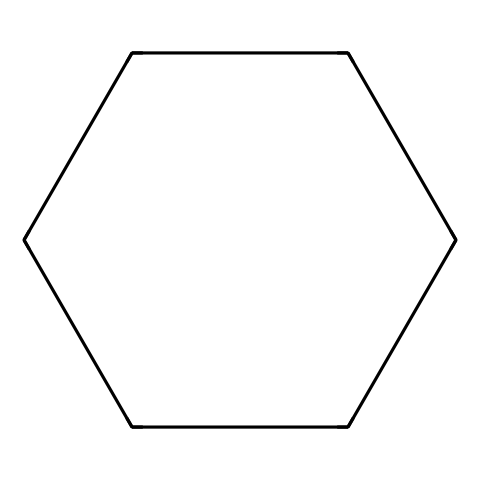What is the name of this chemical? The SMILES representation indicates that this structure corresponds to a six-membered carbon ring with no double bonds, which is characteristic of cyclohexane.
Answer: cyclohexane How many carbon atoms are present in this chemical? By interpreting the SMILES notation, "C1CCCCC1" indicates a total of six carbon atoms forming a cyclic structure.
Answer: six What type of bond is present in the cyclohexane structure? The structure of cyclohexane consists entirely of single bonds, as indicated by the absence of any double bonds in the molecular representation.
Answer: single bonds What is the hybridization of the carbon atoms in cyclohexane? Each carbon atom in the cyclohexane ring is bonded to two other carbons and two hydrogens, which requires sp3 hybridization, typical for alkanes.
Answer: sp3 Is cyclohexane a polar or nonpolar molecule? Due to its symmetrical ring structure and lack of polar functional groups, cyclohexane is evaluated as a nonpolar molecule.
Answer: nonpolar What physical state is cyclohexane at room temperature? Cyclohexane has a boiling point of around 81 degrees Celsius, and at room temperature (about 25 degrees Celsius), it is found in a liquid state.
Answer: liquid What is the main type of chemical reaction that cyclohexane can undergo? Cyclohexane can undergo reactions typical of alkanes, such as substitution and combustion, due to its saturated structure.
Answer: substitution and combustion 